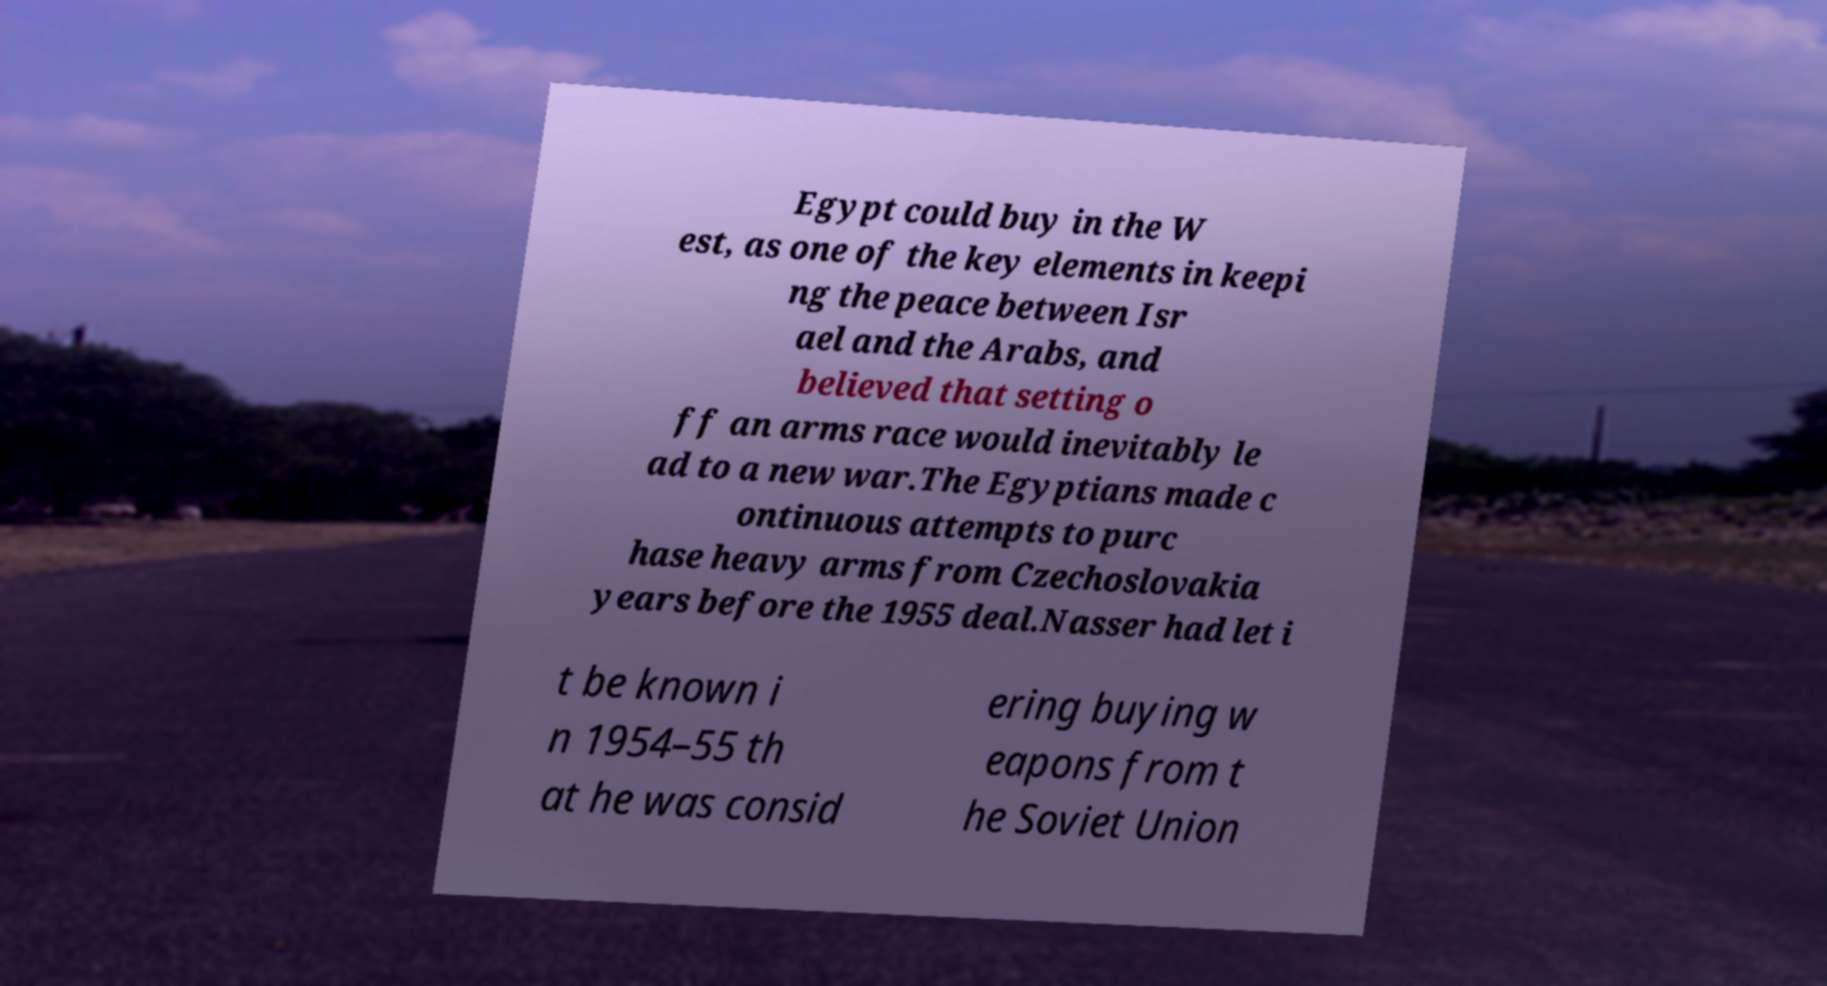I need the written content from this picture converted into text. Can you do that? Egypt could buy in the W est, as one of the key elements in keepi ng the peace between Isr ael and the Arabs, and believed that setting o ff an arms race would inevitably le ad to a new war.The Egyptians made c ontinuous attempts to purc hase heavy arms from Czechoslovakia years before the 1955 deal.Nasser had let i t be known i n 1954–55 th at he was consid ering buying w eapons from t he Soviet Union 